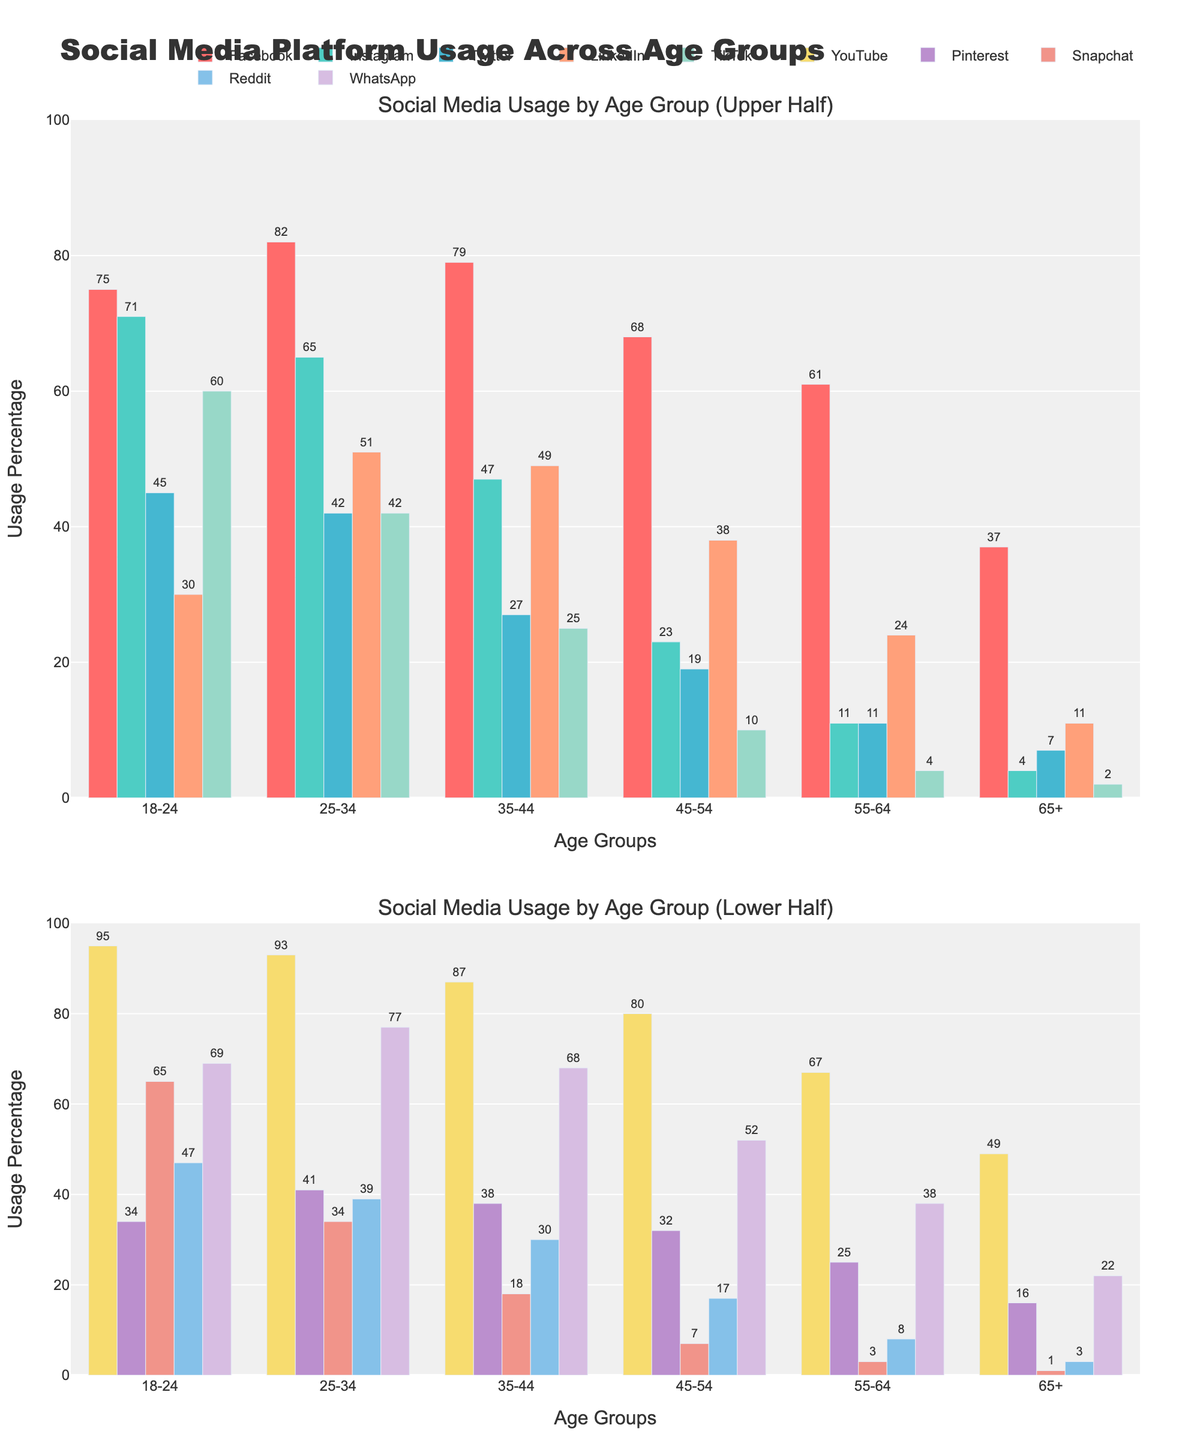What's the most used social media platform for the age group 25-34? The figure shows usage percentages of platforms across age groups. For the age group 25-34, look for the highest bar among the platforms. YouTube has the highest percentage at 93%.
Answer: YouTube Which platform shows a dramatic drop in usage between the 18-24 and 25-34 age groups? Compare the heights of the bars for the 18-24 and 25-34 age groups. Snapchat shows a significant drop from 65% to 34%.
Answer: Snapchat What is the average usage percentage of LinkedIn across all age groups? Add the percentages for LinkedIn across all age groups (30+51+49+38+24+11) to get 203, then divide by the number of age groups, 6, giving (203/6 ≈ 33.83).
Answer: Approximately 33.83% Which social media platform has a consistent decline in usage as the age group increases? Investigate the bars' heights for each platform across age groups. Instagram and TikTok both show consistent declines.
Answer: Instagram, TikTok What platforms have more than 50% usage in the 35-44 age group? Locate the 35-44 age group bars and identify those exceeding 50%. Facebook, YouTube, and WhatsApp meet this criterion.
Answer: Facebook, YouTube, WhatsApp Between Twitter and Reddit, which platform has higher usage in the 45-54 age group? Compare the bar heights for the 45-54 age group for Twitter and Reddit. Twitter (19%) is higher than Reddit (17%).
Answer: Twitter What is the combined percentage usage of Pinterest and Snapchat for the 55-64 age group? Add the percentages for Pinterest and Snapchat in the 55-64 age group, 25% for Pinterest and 3% for Snapchat (25 + 3 = 28).
Answer: 28% Which age group has the highest usage percentage for WhatsApp? Look for the tallest bar for WhatsApp across all age groups. The age group 25-34 has the highest usage at 77%.
Answer: 25-34 What is the difference in YouTube usage between the 18-24 and 65+ age groups? Subtract the 65+ percentage from the 18-24 percentage for YouTube (95% - 49% = 46%).
Answer: 46% Which platform's usage is least affected by age, based on the visual attributes of the bars? Evaluate the consistency of the bar heights for each platform. YouTube shows relatively high and steady usage across all age groups.
Answer: YouTube 